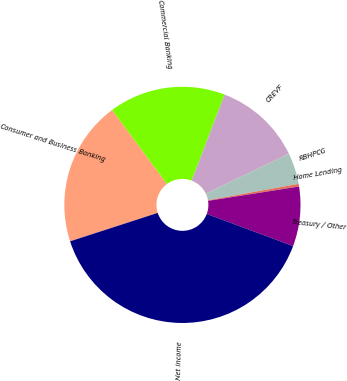Convert chart to OTSL. <chart><loc_0><loc_0><loc_500><loc_500><pie_chart><fcel>Consumer and Business Banking<fcel>Commercial Banking<fcel>CREVF<fcel>RBHPCG<fcel>Home Lending<fcel>Treasury / Other<fcel>Net income<nl><fcel>19.85%<fcel>15.96%<fcel>12.06%<fcel>4.27%<fcel>0.37%<fcel>8.16%<fcel>39.33%<nl></chart> 